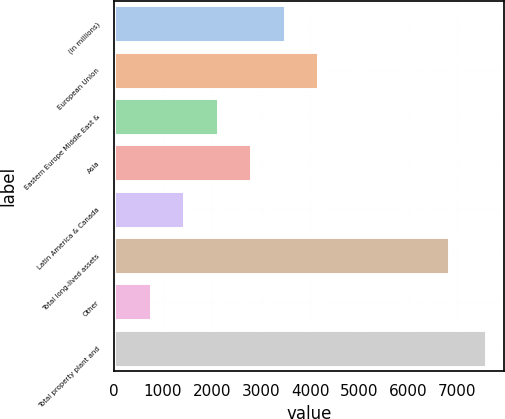Convert chart to OTSL. <chart><loc_0><loc_0><loc_500><loc_500><bar_chart><fcel>(in millions)<fcel>European Union<fcel>Eastern Europe Middle East &<fcel>Asia<fcel>Latin America & Canada<fcel>Total long-lived assets<fcel>Other<fcel>Total property plant and<nl><fcel>3481.6<fcel>4164.5<fcel>2115.8<fcel>2798.7<fcel>1432.9<fcel>6829<fcel>750<fcel>7579<nl></chart> 